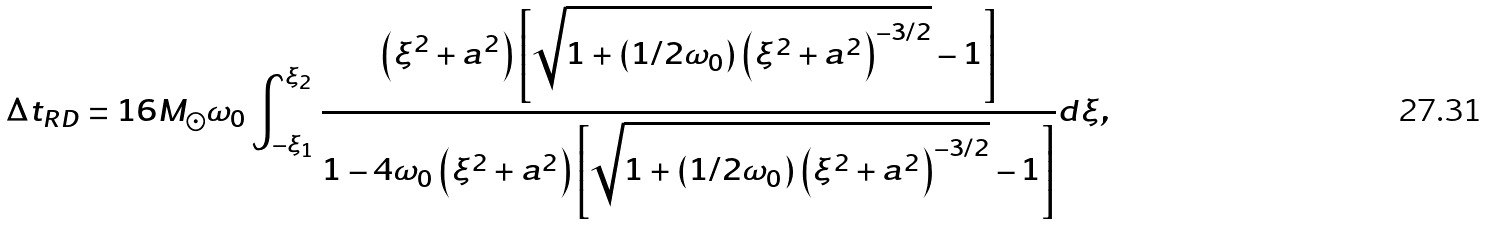<formula> <loc_0><loc_0><loc_500><loc_500>\Delta t _ { R D } = 1 6 M _ { \odot } \omega _ { 0 } \int _ { - \xi _ { 1 } } ^ { \xi _ { 2 } } \frac { \left ( \xi ^ { 2 } + a ^ { 2 } \right ) \left [ \sqrt { 1 + \left ( 1 / 2 \omega _ { 0 } \right ) \left ( \xi ^ { 2 } + a ^ { 2 } \right ) ^ { - 3 / 2 } } - 1 \right ] } { 1 - 4 \omega _ { 0 } \left ( \xi ^ { 2 } + a ^ { 2 } \right ) \left [ \sqrt { 1 + \left ( 1 / 2 \omega _ { 0 } \right ) \left ( \xi ^ { 2 } + a ^ { 2 } \right ) ^ { - 3 / 2 } } - 1 \right ] } d \xi ,</formula> 